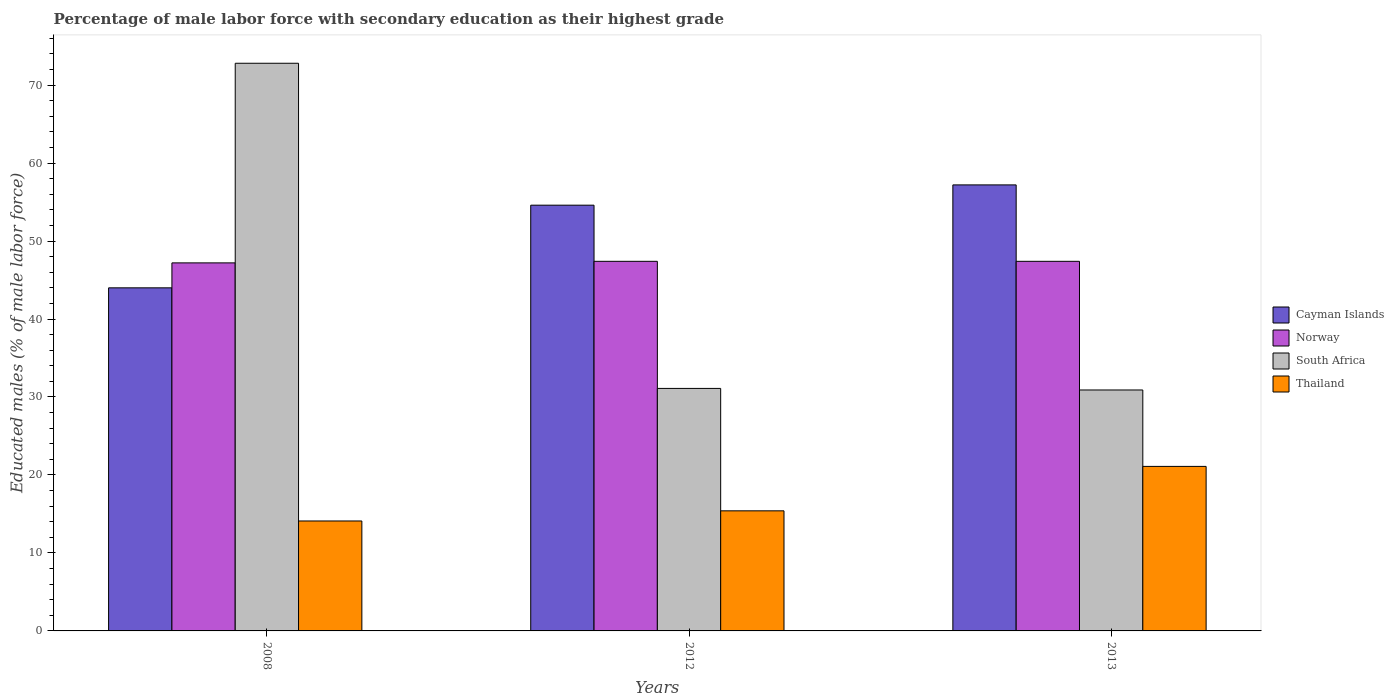Are the number of bars per tick equal to the number of legend labels?
Give a very brief answer. Yes. Are the number of bars on each tick of the X-axis equal?
Ensure brevity in your answer.  Yes. In how many cases, is the number of bars for a given year not equal to the number of legend labels?
Give a very brief answer. 0. What is the percentage of male labor force with secondary education in Norway in 2008?
Provide a succinct answer. 47.2. Across all years, what is the maximum percentage of male labor force with secondary education in Thailand?
Your answer should be compact. 21.1. Across all years, what is the minimum percentage of male labor force with secondary education in South Africa?
Your response must be concise. 30.9. In which year was the percentage of male labor force with secondary education in South Africa minimum?
Provide a succinct answer. 2013. What is the total percentage of male labor force with secondary education in South Africa in the graph?
Provide a succinct answer. 134.8. What is the difference between the percentage of male labor force with secondary education in South Africa in 2008 and that in 2012?
Give a very brief answer. 41.7. What is the difference between the percentage of male labor force with secondary education in Norway in 2012 and the percentage of male labor force with secondary education in South Africa in 2013?
Your answer should be compact. 16.5. What is the average percentage of male labor force with secondary education in Thailand per year?
Make the answer very short. 16.87. In the year 2008, what is the difference between the percentage of male labor force with secondary education in Norway and percentage of male labor force with secondary education in South Africa?
Offer a very short reply. -25.6. In how many years, is the percentage of male labor force with secondary education in Cayman Islands greater than 2 %?
Provide a succinct answer. 3. What is the ratio of the percentage of male labor force with secondary education in Norway in 2008 to that in 2012?
Give a very brief answer. 1. What is the difference between the highest and the second highest percentage of male labor force with secondary education in Thailand?
Your response must be concise. 5.7. What is the difference between the highest and the lowest percentage of male labor force with secondary education in Cayman Islands?
Provide a succinct answer. 13.2. In how many years, is the percentage of male labor force with secondary education in Thailand greater than the average percentage of male labor force with secondary education in Thailand taken over all years?
Provide a succinct answer. 1. Is the sum of the percentage of male labor force with secondary education in Cayman Islands in 2008 and 2012 greater than the maximum percentage of male labor force with secondary education in South Africa across all years?
Provide a short and direct response. Yes. Is it the case that in every year, the sum of the percentage of male labor force with secondary education in Cayman Islands and percentage of male labor force with secondary education in Thailand is greater than the sum of percentage of male labor force with secondary education in South Africa and percentage of male labor force with secondary education in Norway?
Provide a short and direct response. No. What does the 2nd bar from the left in 2013 represents?
Offer a terse response. Norway. What does the 4th bar from the right in 2012 represents?
Provide a succinct answer. Cayman Islands. Are the values on the major ticks of Y-axis written in scientific E-notation?
Keep it short and to the point. No. Does the graph contain any zero values?
Keep it short and to the point. No. How many legend labels are there?
Your response must be concise. 4. What is the title of the graph?
Provide a succinct answer. Percentage of male labor force with secondary education as their highest grade. Does "Other small states" appear as one of the legend labels in the graph?
Make the answer very short. No. What is the label or title of the X-axis?
Offer a terse response. Years. What is the label or title of the Y-axis?
Provide a short and direct response. Educated males (% of male labor force). What is the Educated males (% of male labor force) in Norway in 2008?
Ensure brevity in your answer.  47.2. What is the Educated males (% of male labor force) in South Africa in 2008?
Provide a succinct answer. 72.8. What is the Educated males (% of male labor force) in Thailand in 2008?
Give a very brief answer. 14.1. What is the Educated males (% of male labor force) in Cayman Islands in 2012?
Your answer should be compact. 54.6. What is the Educated males (% of male labor force) in Norway in 2012?
Your answer should be compact. 47.4. What is the Educated males (% of male labor force) of South Africa in 2012?
Your response must be concise. 31.1. What is the Educated males (% of male labor force) in Thailand in 2012?
Your answer should be very brief. 15.4. What is the Educated males (% of male labor force) in Cayman Islands in 2013?
Ensure brevity in your answer.  57.2. What is the Educated males (% of male labor force) of Norway in 2013?
Your answer should be compact. 47.4. What is the Educated males (% of male labor force) of South Africa in 2013?
Your response must be concise. 30.9. What is the Educated males (% of male labor force) of Thailand in 2013?
Give a very brief answer. 21.1. Across all years, what is the maximum Educated males (% of male labor force) of Cayman Islands?
Ensure brevity in your answer.  57.2. Across all years, what is the maximum Educated males (% of male labor force) of Norway?
Give a very brief answer. 47.4. Across all years, what is the maximum Educated males (% of male labor force) of South Africa?
Provide a succinct answer. 72.8. Across all years, what is the maximum Educated males (% of male labor force) of Thailand?
Keep it short and to the point. 21.1. Across all years, what is the minimum Educated males (% of male labor force) of Norway?
Your answer should be compact. 47.2. Across all years, what is the minimum Educated males (% of male labor force) of South Africa?
Make the answer very short. 30.9. Across all years, what is the minimum Educated males (% of male labor force) of Thailand?
Ensure brevity in your answer.  14.1. What is the total Educated males (% of male labor force) in Cayman Islands in the graph?
Your answer should be compact. 155.8. What is the total Educated males (% of male labor force) of Norway in the graph?
Offer a very short reply. 142. What is the total Educated males (% of male labor force) in South Africa in the graph?
Make the answer very short. 134.8. What is the total Educated males (% of male labor force) in Thailand in the graph?
Offer a terse response. 50.6. What is the difference between the Educated males (% of male labor force) of Cayman Islands in 2008 and that in 2012?
Offer a terse response. -10.6. What is the difference between the Educated males (% of male labor force) of South Africa in 2008 and that in 2012?
Offer a terse response. 41.7. What is the difference between the Educated males (% of male labor force) in Thailand in 2008 and that in 2012?
Your response must be concise. -1.3. What is the difference between the Educated males (% of male labor force) of South Africa in 2008 and that in 2013?
Provide a succinct answer. 41.9. What is the difference between the Educated males (% of male labor force) in South Africa in 2012 and that in 2013?
Your answer should be very brief. 0.2. What is the difference between the Educated males (% of male labor force) in Cayman Islands in 2008 and the Educated males (% of male labor force) in Norway in 2012?
Ensure brevity in your answer.  -3.4. What is the difference between the Educated males (% of male labor force) of Cayman Islands in 2008 and the Educated males (% of male labor force) of Thailand in 2012?
Your response must be concise. 28.6. What is the difference between the Educated males (% of male labor force) of Norway in 2008 and the Educated males (% of male labor force) of Thailand in 2012?
Ensure brevity in your answer.  31.8. What is the difference between the Educated males (% of male labor force) in South Africa in 2008 and the Educated males (% of male labor force) in Thailand in 2012?
Offer a very short reply. 57.4. What is the difference between the Educated males (% of male labor force) of Cayman Islands in 2008 and the Educated males (% of male labor force) of Norway in 2013?
Give a very brief answer. -3.4. What is the difference between the Educated males (% of male labor force) in Cayman Islands in 2008 and the Educated males (% of male labor force) in Thailand in 2013?
Provide a succinct answer. 22.9. What is the difference between the Educated males (% of male labor force) in Norway in 2008 and the Educated males (% of male labor force) in Thailand in 2013?
Your answer should be compact. 26.1. What is the difference between the Educated males (% of male labor force) of South Africa in 2008 and the Educated males (% of male labor force) of Thailand in 2013?
Make the answer very short. 51.7. What is the difference between the Educated males (% of male labor force) in Cayman Islands in 2012 and the Educated males (% of male labor force) in Norway in 2013?
Provide a short and direct response. 7.2. What is the difference between the Educated males (% of male labor force) in Cayman Islands in 2012 and the Educated males (% of male labor force) in South Africa in 2013?
Give a very brief answer. 23.7. What is the difference between the Educated males (% of male labor force) of Cayman Islands in 2012 and the Educated males (% of male labor force) of Thailand in 2013?
Ensure brevity in your answer.  33.5. What is the difference between the Educated males (% of male labor force) in Norway in 2012 and the Educated males (% of male labor force) in Thailand in 2013?
Give a very brief answer. 26.3. What is the average Educated males (% of male labor force) of Cayman Islands per year?
Offer a terse response. 51.93. What is the average Educated males (% of male labor force) of Norway per year?
Offer a very short reply. 47.33. What is the average Educated males (% of male labor force) of South Africa per year?
Offer a very short reply. 44.93. What is the average Educated males (% of male labor force) in Thailand per year?
Offer a terse response. 16.87. In the year 2008, what is the difference between the Educated males (% of male labor force) of Cayman Islands and Educated males (% of male labor force) of Norway?
Give a very brief answer. -3.2. In the year 2008, what is the difference between the Educated males (% of male labor force) in Cayman Islands and Educated males (% of male labor force) in South Africa?
Keep it short and to the point. -28.8. In the year 2008, what is the difference between the Educated males (% of male labor force) in Cayman Islands and Educated males (% of male labor force) in Thailand?
Make the answer very short. 29.9. In the year 2008, what is the difference between the Educated males (% of male labor force) in Norway and Educated males (% of male labor force) in South Africa?
Ensure brevity in your answer.  -25.6. In the year 2008, what is the difference between the Educated males (% of male labor force) of Norway and Educated males (% of male labor force) of Thailand?
Your answer should be compact. 33.1. In the year 2008, what is the difference between the Educated males (% of male labor force) of South Africa and Educated males (% of male labor force) of Thailand?
Make the answer very short. 58.7. In the year 2012, what is the difference between the Educated males (% of male labor force) of Cayman Islands and Educated males (% of male labor force) of South Africa?
Provide a short and direct response. 23.5. In the year 2012, what is the difference between the Educated males (% of male labor force) in Cayman Islands and Educated males (% of male labor force) in Thailand?
Offer a very short reply. 39.2. In the year 2012, what is the difference between the Educated males (% of male labor force) in Norway and Educated males (% of male labor force) in South Africa?
Give a very brief answer. 16.3. In the year 2012, what is the difference between the Educated males (% of male labor force) in Norway and Educated males (% of male labor force) in Thailand?
Provide a short and direct response. 32. In the year 2013, what is the difference between the Educated males (% of male labor force) of Cayman Islands and Educated males (% of male labor force) of Norway?
Your answer should be very brief. 9.8. In the year 2013, what is the difference between the Educated males (% of male labor force) in Cayman Islands and Educated males (% of male labor force) in South Africa?
Your answer should be very brief. 26.3. In the year 2013, what is the difference between the Educated males (% of male labor force) of Cayman Islands and Educated males (% of male labor force) of Thailand?
Give a very brief answer. 36.1. In the year 2013, what is the difference between the Educated males (% of male labor force) of Norway and Educated males (% of male labor force) of Thailand?
Provide a succinct answer. 26.3. In the year 2013, what is the difference between the Educated males (% of male labor force) in South Africa and Educated males (% of male labor force) in Thailand?
Keep it short and to the point. 9.8. What is the ratio of the Educated males (% of male labor force) in Cayman Islands in 2008 to that in 2012?
Give a very brief answer. 0.81. What is the ratio of the Educated males (% of male labor force) in South Africa in 2008 to that in 2012?
Your answer should be very brief. 2.34. What is the ratio of the Educated males (% of male labor force) of Thailand in 2008 to that in 2012?
Make the answer very short. 0.92. What is the ratio of the Educated males (% of male labor force) of Cayman Islands in 2008 to that in 2013?
Offer a very short reply. 0.77. What is the ratio of the Educated males (% of male labor force) of South Africa in 2008 to that in 2013?
Ensure brevity in your answer.  2.36. What is the ratio of the Educated males (% of male labor force) in Thailand in 2008 to that in 2013?
Provide a succinct answer. 0.67. What is the ratio of the Educated males (% of male labor force) in Cayman Islands in 2012 to that in 2013?
Offer a very short reply. 0.95. What is the ratio of the Educated males (% of male labor force) in Norway in 2012 to that in 2013?
Make the answer very short. 1. What is the ratio of the Educated males (% of male labor force) in South Africa in 2012 to that in 2013?
Give a very brief answer. 1.01. What is the ratio of the Educated males (% of male labor force) of Thailand in 2012 to that in 2013?
Provide a short and direct response. 0.73. What is the difference between the highest and the second highest Educated males (% of male labor force) in Cayman Islands?
Provide a short and direct response. 2.6. What is the difference between the highest and the second highest Educated males (% of male labor force) in South Africa?
Make the answer very short. 41.7. What is the difference between the highest and the second highest Educated males (% of male labor force) in Thailand?
Your answer should be compact. 5.7. What is the difference between the highest and the lowest Educated males (% of male labor force) of Cayman Islands?
Provide a succinct answer. 13.2. What is the difference between the highest and the lowest Educated males (% of male labor force) in Norway?
Give a very brief answer. 0.2. What is the difference between the highest and the lowest Educated males (% of male labor force) in South Africa?
Give a very brief answer. 41.9. What is the difference between the highest and the lowest Educated males (% of male labor force) in Thailand?
Give a very brief answer. 7. 